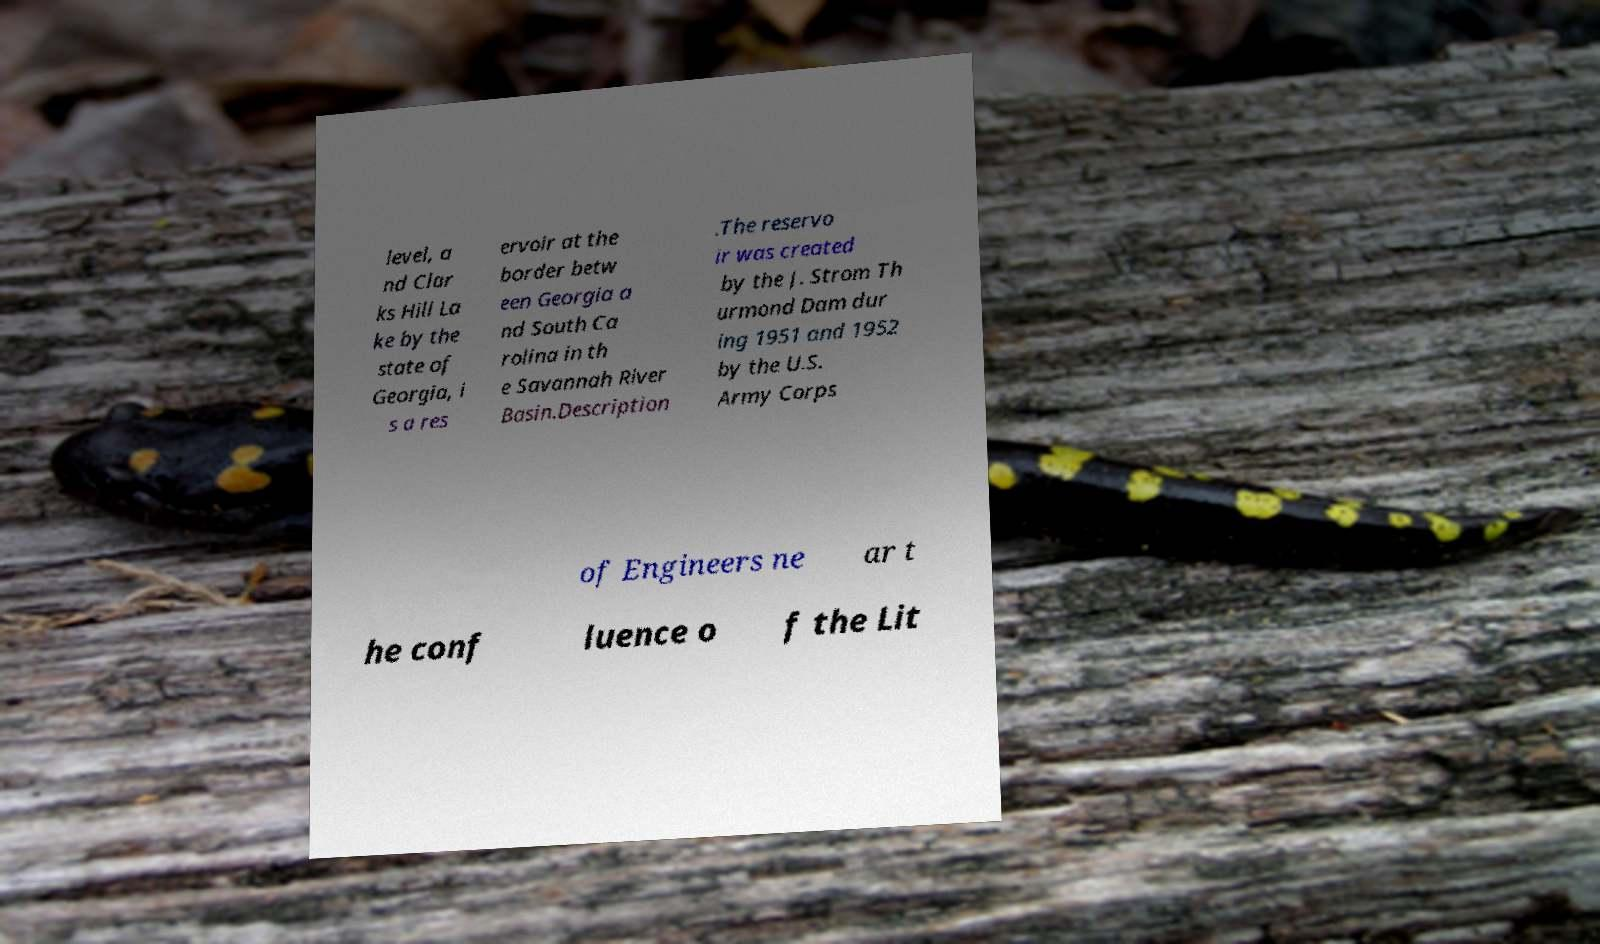Please read and relay the text visible in this image. What does it say? level, a nd Clar ks Hill La ke by the state of Georgia, i s a res ervoir at the border betw een Georgia a nd South Ca rolina in th e Savannah River Basin.Description .The reservo ir was created by the J. Strom Th urmond Dam dur ing 1951 and 1952 by the U.S. Army Corps of Engineers ne ar t he conf luence o f the Lit 